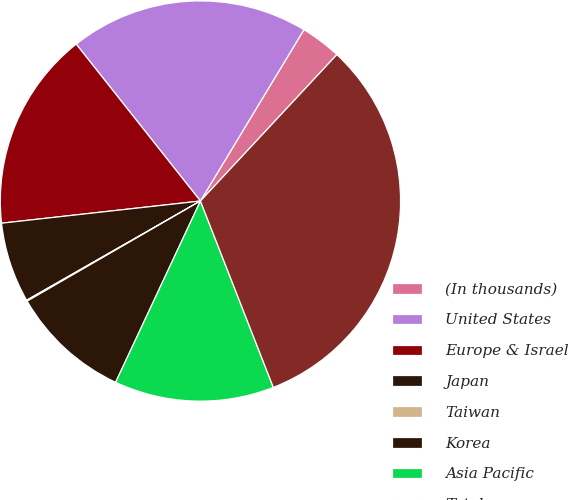Convert chart. <chart><loc_0><loc_0><loc_500><loc_500><pie_chart><fcel>(In thousands)<fcel>United States<fcel>Europe & Israel<fcel>Japan<fcel>Taiwan<fcel>Korea<fcel>Asia Pacific<fcel>Total<nl><fcel>3.29%<fcel>19.31%<fcel>16.11%<fcel>6.49%<fcel>0.08%<fcel>9.7%<fcel>12.9%<fcel>32.13%<nl></chart> 